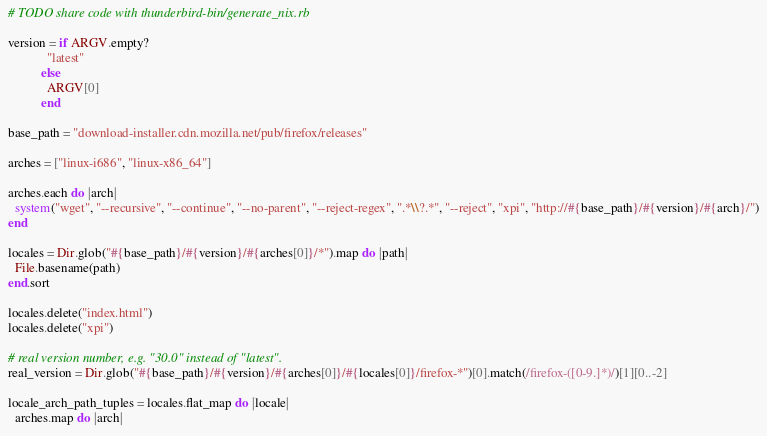<code> <loc_0><loc_0><loc_500><loc_500><_Ruby_># TODO share code with thunderbird-bin/generate_nix.rb

version = if ARGV.empty?
            "latest"
          else
            ARGV[0]
          end

base_path = "download-installer.cdn.mozilla.net/pub/firefox/releases"

arches = ["linux-i686", "linux-x86_64"]

arches.each do |arch|
  system("wget", "--recursive", "--continue", "--no-parent", "--reject-regex", ".*\\?.*", "--reject", "xpi", "http://#{base_path}/#{version}/#{arch}/")
end

locales = Dir.glob("#{base_path}/#{version}/#{arches[0]}/*").map do |path|
  File.basename(path)
end.sort

locales.delete("index.html")
locales.delete("xpi")

# real version number, e.g. "30.0" instead of "latest".
real_version = Dir.glob("#{base_path}/#{version}/#{arches[0]}/#{locales[0]}/firefox-*")[0].match(/firefox-([0-9.]*)/)[1][0..-2]

locale_arch_path_tuples = locales.flat_map do |locale|
  arches.map do |arch|</code> 